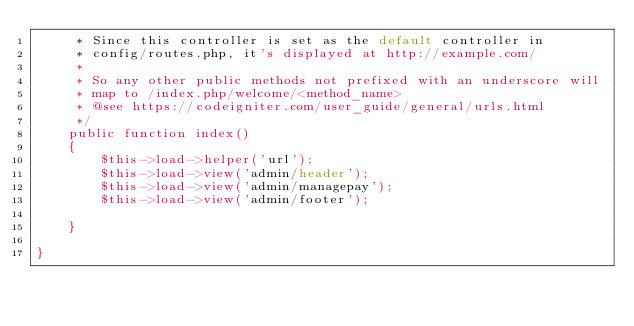Convert code to text. <code><loc_0><loc_0><loc_500><loc_500><_PHP_>	 * Since this controller is set as the default controller in
	 * config/routes.php, it's displayed at http://example.com/
	 *
	 * So any other public methods not prefixed with an underscore will
	 * map to /index.php/welcome/<method_name>
	 * @see https://codeigniter.com/user_guide/general/urls.html
	 */
	public function index()
	{
		$this->load->helper('url');
		$this->load->view('admin/header');
		$this->load->view('admin/managepay');
		$this->load->view('admin/footer');
		
	}
	
}
</code> 